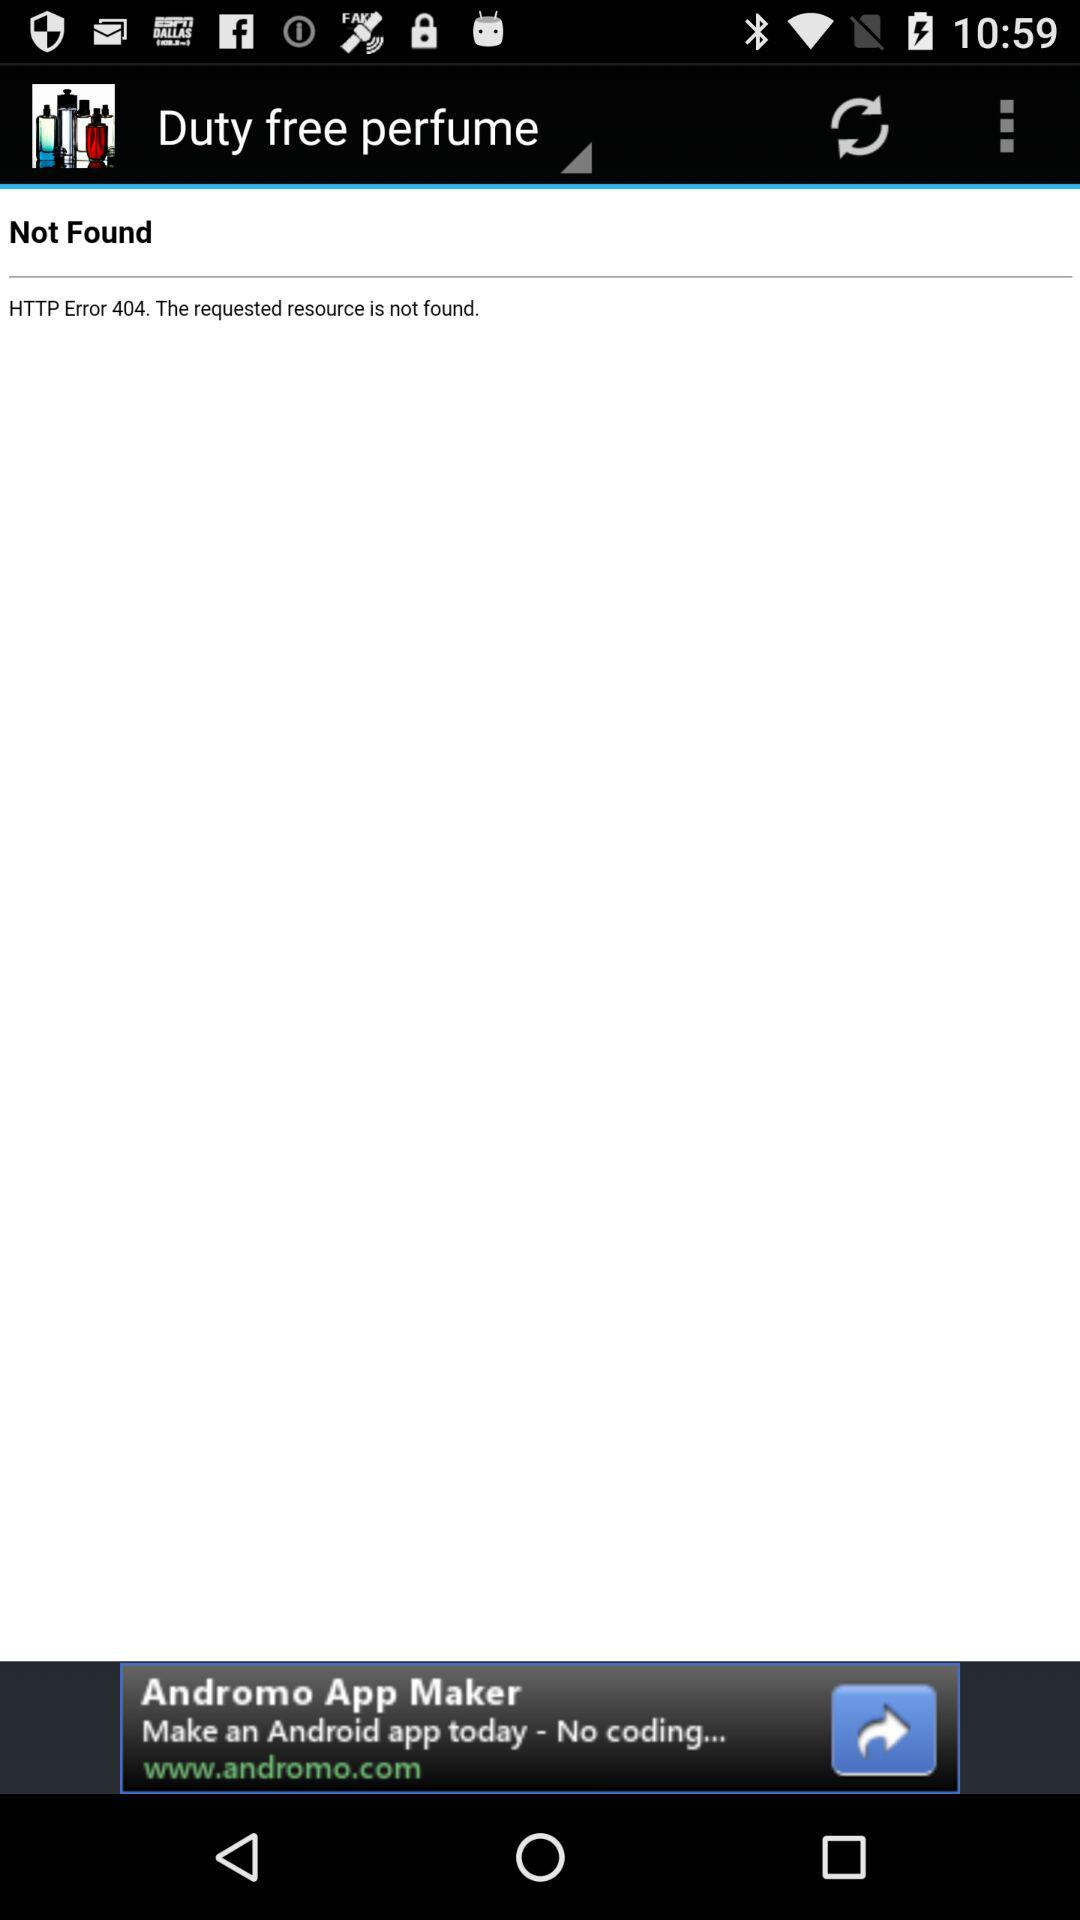What error occurs? The error is "HTTP Error 404. The requested resource is not found". 